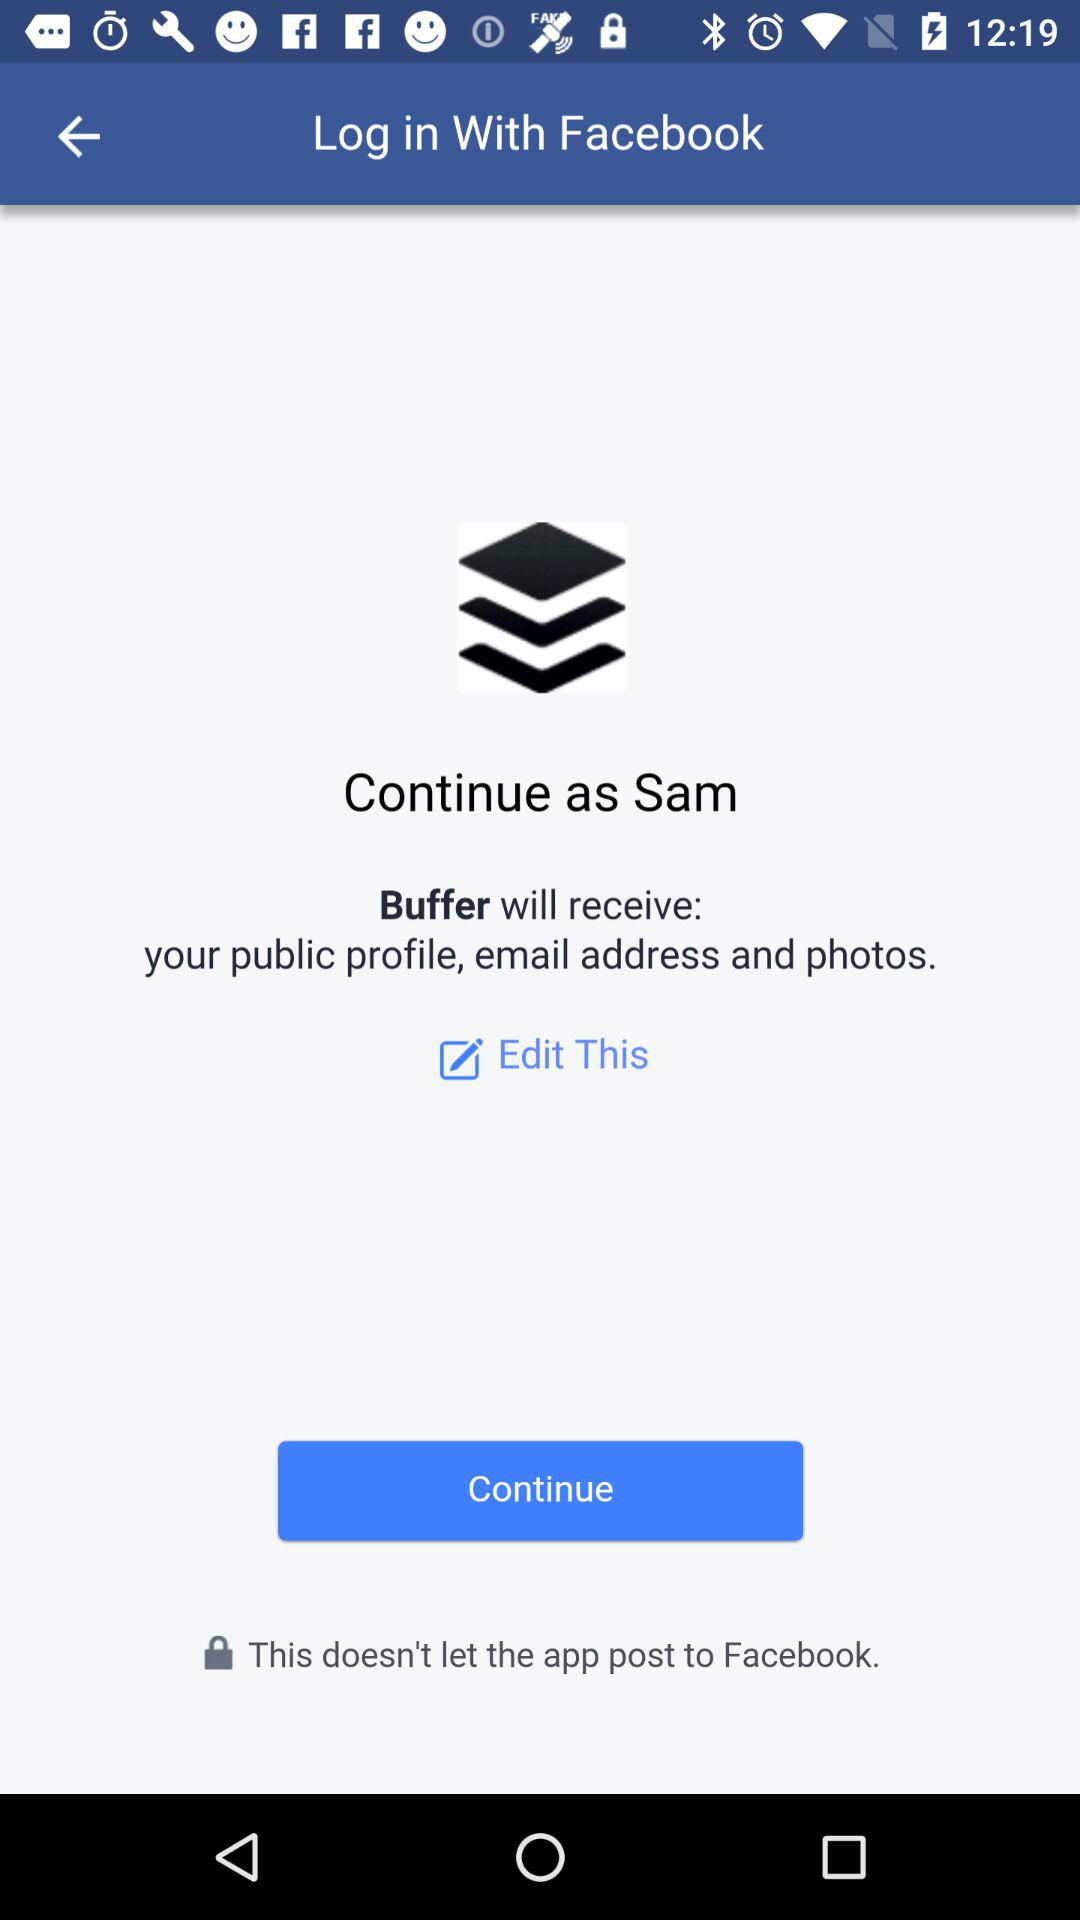What application can be used to log in? The application that can be used to log in is "Facebook". 